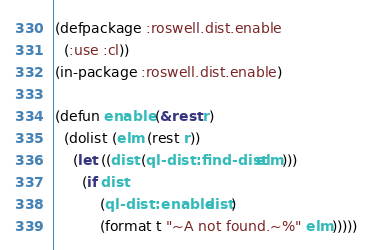Convert code to text. <code><loc_0><loc_0><loc_500><loc_500><_Lisp_>(defpackage :roswell.dist.enable
  (:use :cl))
(in-package :roswell.dist.enable)

(defun enable (&rest r)
  (dolist (elm (rest r))
    (let ((dist (ql-dist:find-dist elm)))
      (if dist
          (ql-dist:enable dist)
          (format t "~A not found.~%" elm)))))
</code> 